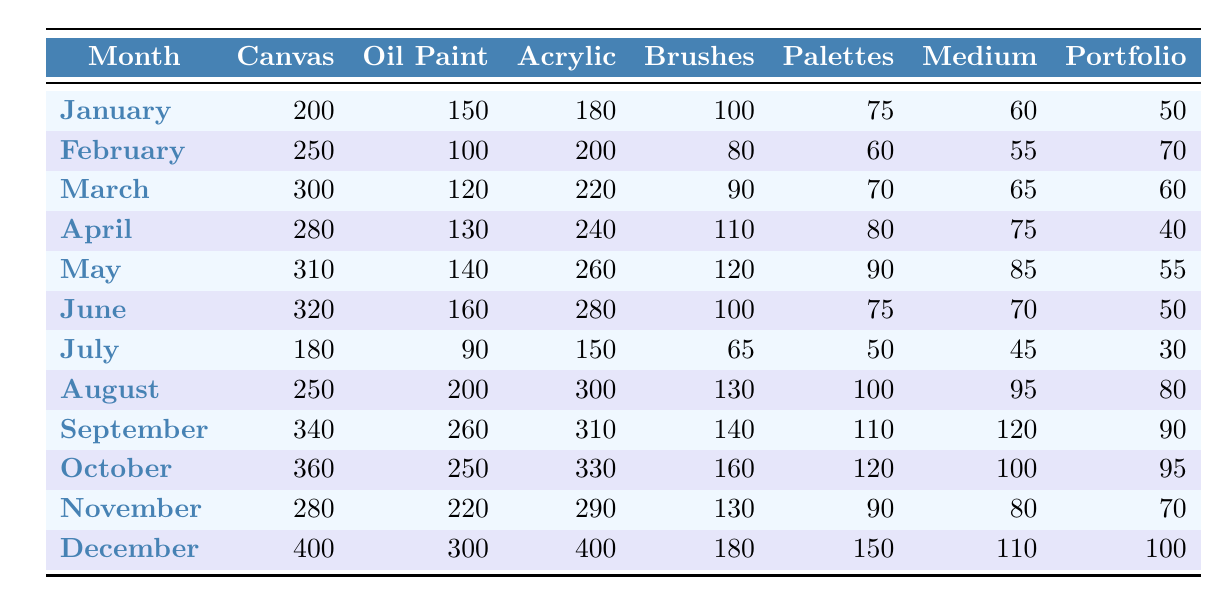What month had the highest canvas sales? By examining the canvas sales column, December shows the highest number at 400.
Answer: December Which month saw the lowest brush sales? Looking through the brush sales data, July has the lowest count at 65.
Answer: July What are the total sales of acrylic paint from March to May? Adding the acrylic paint sales from March (220), April (240), and May (260) gives a total of 220 + 240 + 260 = 720.
Answer: 720 In which month was the oil paint sales greater than 200? Checking the oil paint sales figures, oil paint sales exceeded 200 in August (200) and December (300).
Answer: August and December What was the average portfolio sales from January to June? Summing the portfolio sales for January (50), February (70), March (60), April (40), May (55), June (50): 50 + 70 + 60 + 40 + 55 + 50 = 325; there are 6 months, so the average is 325 / 6 ≈ 54.17.
Answer: 54.17 Did sales of oil paint increase from January to February? Comparing the oil paint sales, January recorded 150 while February had 100, which indicates a decrease.
Answer: No What is the difference in canvas sales between September and November? Canvas sales for September are 340 and for November are 280, thus the difference is 340 - 280 = 60.
Answer: 60 How did the acrylic paint sales trend from January to December? Observing the acrylic paint sales, they increased from 180 in January to 400 in December. This indicates a consistent upward trend.
Answer: Upward trend What was the total sales of all supplies in December? Adding together all supplies in December gives: 400 (canvas) + 300 (oil paint) + 400 (acrylic) + 180 (brushes) + 150 (palettes) + 110 (medium) + 100 (portfolio) = 1740.
Answer: 1740 Which type of supply had the biggest sales increase from July to August? Comparing sales from July and August: canvas sales change from 180 to 250 (increase of 70), oil paint from 90 to 200 (increase of 110), acrylic from 150 to 300 (increase of 150). The biggest increase is in acrylic paint.
Answer: Acrylic paint 